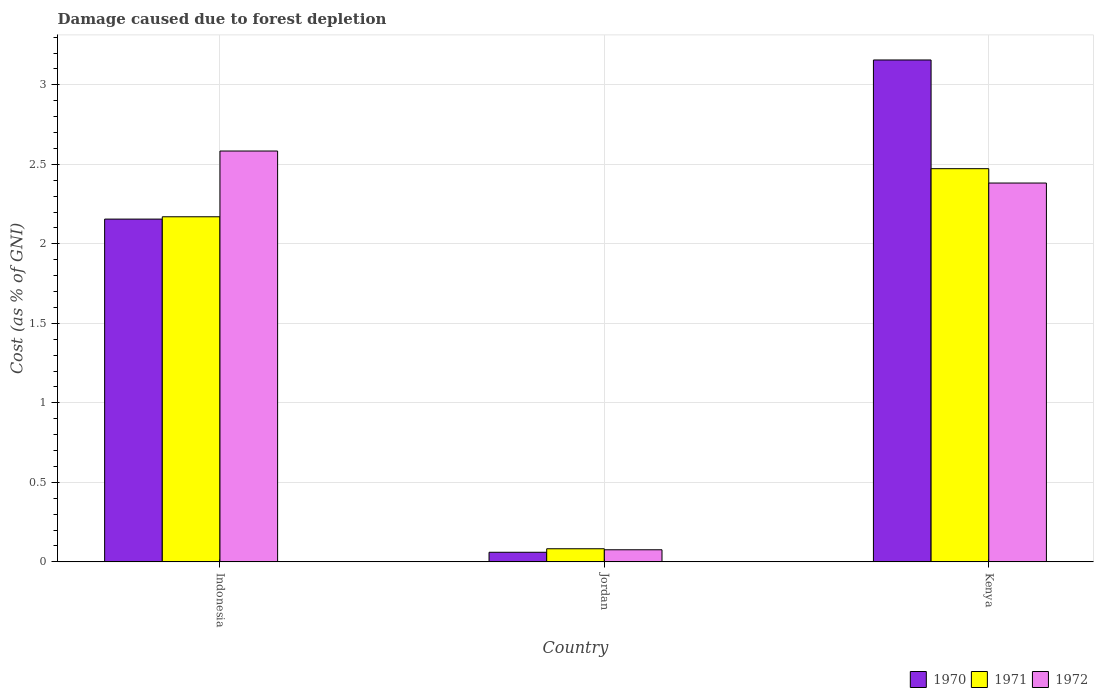How many different coloured bars are there?
Ensure brevity in your answer.  3. How many groups of bars are there?
Your answer should be compact. 3. Are the number of bars per tick equal to the number of legend labels?
Your response must be concise. Yes. How many bars are there on the 1st tick from the left?
Offer a very short reply. 3. What is the label of the 3rd group of bars from the left?
Offer a terse response. Kenya. What is the cost of damage caused due to forest depletion in 1972 in Indonesia?
Your response must be concise. 2.58. Across all countries, what is the maximum cost of damage caused due to forest depletion in 1972?
Give a very brief answer. 2.58. Across all countries, what is the minimum cost of damage caused due to forest depletion in 1970?
Your answer should be compact. 0.06. In which country was the cost of damage caused due to forest depletion in 1971 maximum?
Keep it short and to the point. Kenya. In which country was the cost of damage caused due to forest depletion in 1971 minimum?
Provide a succinct answer. Jordan. What is the total cost of damage caused due to forest depletion in 1970 in the graph?
Provide a succinct answer. 5.37. What is the difference between the cost of damage caused due to forest depletion in 1972 in Indonesia and that in Jordan?
Your answer should be compact. 2.51. What is the difference between the cost of damage caused due to forest depletion in 1972 in Kenya and the cost of damage caused due to forest depletion in 1970 in Indonesia?
Provide a succinct answer. 0.23. What is the average cost of damage caused due to forest depletion in 1972 per country?
Offer a terse response. 1.68. What is the difference between the cost of damage caused due to forest depletion of/in 1970 and cost of damage caused due to forest depletion of/in 1971 in Indonesia?
Your response must be concise. -0.01. In how many countries, is the cost of damage caused due to forest depletion in 1972 greater than 1.8 %?
Offer a very short reply. 2. What is the ratio of the cost of damage caused due to forest depletion in 1972 in Indonesia to that in Kenya?
Your answer should be very brief. 1.08. Is the cost of damage caused due to forest depletion in 1971 in Indonesia less than that in Kenya?
Keep it short and to the point. Yes. What is the difference between the highest and the second highest cost of damage caused due to forest depletion in 1970?
Give a very brief answer. -2.1. What is the difference between the highest and the lowest cost of damage caused due to forest depletion in 1972?
Offer a very short reply. 2.51. In how many countries, is the cost of damage caused due to forest depletion in 1971 greater than the average cost of damage caused due to forest depletion in 1971 taken over all countries?
Your answer should be compact. 2. Is the sum of the cost of damage caused due to forest depletion in 1970 in Indonesia and Jordan greater than the maximum cost of damage caused due to forest depletion in 1972 across all countries?
Ensure brevity in your answer.  No. What does the 3rd bar from the right in Jordan represents?
Your answer should be very brief. 1970. How many bars are there?
Your answer should be very brief. 9. Are all the bars in the graph horizontal?
Provide a short and direct response. No. Are the values on the major ticks of Y-axis written in scientific E-notation?
Offer a very short reply. No. What is the title of the graph?
Make the answer very short. Damage caused due to forest depletion. What is the label or title of the X-axis?
Keep it short and to the point. Country. What is the label or title of the Y-axis?
Offer a terse response. Cost (as % of GNI). What is the Cost (as % of GNI) in 1970 in Indonesia?
Offer a terse response. 2.16. What is the Cost (as % of GNI) in 1971 in Indonesia?
Give a very brief answer. 2.17. What is the Cost (as % of GNI) in 1972 in Indonesia?
Keep it short and to the point. 2.58. What is the Cost (as % of GNI) in 1970 in Jordan?
Offer a terse response. 0.06. What is the Cost (as % of GNI) of 1971 in Jordan?
Offer a terse response. 0.08. What is the Cost (as % of GNI) in 1972 in Jordan?
Your answer should be very brief. 0.08. What is the Cost (as % of GNI) of 1970 in Kenya?
Offer a terse response. 3.16. What is the Cost (as % of GNI) in 1971 in Kenya?
Give a very brief answer. 2.47. What is the Cost (as % of GNI) of 1972 in Kenya?
Give a very brief answer. 2.38. Across all countries, what is the maximum Cost (as % of GNI) of 1970?
Your answer should be very brief. 3.16. Across all countries, what is the maximum Cost (as % of GNI) of 1971?
Your answer should be very brief. 2.47. Across all countries, what is the maximum Cost (as % of GNI) in 1972?
Offer a terse response. 2.58. Across all countries, what is the minimum Cost (as % of GNI) in 1970?
Provide a succinct answer. 0.06. Across all countries, what is the minimum Cost (as % of GNI) of 1971?
Your answer should be compact. 0.08. Across all countries, what is the minimum Cost (as % of GNI) in 1972?
Give a very brief answer. 0.08. What is the total Cost (as % of GNI) in 1970 in the graph?
Keep it short and to the point. 5.37. What is the total Cost (as % of GNI) in 1971 in the graph?
Your answer should be compact. 4.73. What is the total Cost (as % of GNI) in 1972 in the graph?
Ensure brevity in your answer.  5.04. What is the difference between the Cost (as % of GNI) of 1970 in Indonesia and that in Jordan?
Ensure brevity in your answer.  2.1. What is the difference between the Cost (as % of GNI) of 1971 in Indonesia and that in Jordan?
Your response must be concise. 2.09. What is the difference between the Cost (as % of GNI) of 1972 in Indonesia and that in Jordan?
Provide a succinct answer. 2.51. What is the difference between the Cost (as % of GNI) in 1970 in Indonesia and that in Kenya?
Your response must be concise. -1. What is the difference between the Cost (as % of GNI) of 1971 in Indonesia and that in Kenya?
Ensure brevity in your answer.  -0.3. What is the difference between the Cost (as % of GNI) of 1972 in Indonesia and that in Kenya?
Offer a terse response. 0.2. What is the difference between the Cost (as % of GNI) in 1970 in Jordan and that in Kenya?
Your response must be concise. -3.1. What is the difference between the Cost (as % of GNI) of 1971 in Jordan and that in Kenya?
Give a very brief answer. -2.39. What is the difference between the Cost (as % of GNI) in 1972 in Jordan and that in Kenya?
Provide a short and direct response. -2.31. What is the difference between the Cost (as % of GNI) in 1970 in Indonesia and the Cost (as % of GNI) in 1971 in Jordan?
Ensure brevity in your answer.  2.07. What is the difference between the Cost (as % of GNI) in 1970 in Indonesia and the Cost (as % of GNI) in 1972 in Jordan?
Offer a terse response. 2.08. What is the difference between the Cost (as % of GNI) in 1971 in Indonesia and the Cost (as % of GNI) in 1972 in Jordan?
Offer a very short reply. 2.09. What is the difference between the Cost (as % of GNI) in 1970 in Indonesia and the Cost (as % of GNI) in 1971 in Kenya?
Offer a very short reply. -0.32. What is the difference between the Cost (as % of GNI) of 1970 in Indonesia and the Cost (as % of GNI) of 1972 in Kenya?
Make the answer very short. -0.23. What is the difference between the Cost (as % of GNI) of 1971 in Indonesia and the Cost (as % of GNI) of 1972 in Kenya?
Ensure brevity in your answer.  -0.21. What is the difference between the Cost (as % of GNI) of 1970 in Jordan and the Cost (as % of GNI) of 1971 in Kenya?
Make the answer very short. -2.41. What is the difference between the Cost (as % of GNI) of 1970 in Jordan and the Cost (as % of GNI) of 1972 in Kenya?
Offer a very short reply. -2.32. What is the difference between the Cost (as % of GNI) of 1971 in Jordan and the Cost (as % of GNI) of 1972 in Kenya?
Provide a short and direct response. -2.3. What is the average Cost (as % of GNI) in 1970 per country?
Provide a short and direct response. 1.79. What is the average Cost (as % of GNI) of 1971 per country?
Ensure brevity in your answer.  1.58. What is the average Cost (as % of GNI) in 1972 per country?
Provide a short and direct response. 1.68. What is the difference between the Cost (as % of GNI) of 1970 and Cost (as % of GNI) of 1971 in Indonesia?
Your response must be concise. -0.01. What is the difference between the Cost (as % of GNI) of 1970 and Cost (as % of GNI) of 1972 in Indonesia?
Provide a succinct answer. -0.43. What is the difference between the Cost (as % of GNI) of 1971 and Cost (as % of GNI) of 1972 in Indonesia?
Your response must be concise. -0.41. What is the difference between the Cost (as % of GNI) in 1970 and Cost (as % of GNI) in 1971 in Jordan?
Give a very brief answer. -0.02. What is the difference between the Cost (as % of GNI) of 1970 and Cost (as % of GNI) of 1972 in Jordan?
Make the answer very short. -0.02. What is the difference between the Cost (as % of GNI) of 1971 and Cost (as % of GNI) of 1972 in Jordan?
Provide a short and direct response. 0.01. What is the difference between the Cost (as % of GNI) in 1970 and Cost (as % of GNI) in 1971 in Kenya?
Keep it short and to the point. 0.68. What is the difference between the Cost (as % of GNI) of 1970 and Cost (as % of GNI) of 1972 in Kenya?
Offer a terse response. 0.77. What is the difference between the Cost (as % of GNI) of 1971 and Cost (as % of GNI) of 1972 in Kenya?
Ensure brevity in your answer.  0.09. What is the ratio of the Cost (as % of GNI) of 1970 in Indonesia to that in Jordan?
Provide a succinct answer. 35.71. What is the ratio of the Cost (as % of GNI) of 1971 in Indonesia to that in Jordan?
Ensure brevity in your answer.  26.32. What is the ratio of the Cost (as % of GNI) of 1972 in Indonesia to that in Jordan?
Ensure brevity in your answer.  33.95. What is the ratio of the Cost (as % of GNI) of 1970 in Indonesia to that in Kenya?
Your answer should be compact. 0.68. What is the ratio of the Cost (as % of GNI) of 1971 in Indonesia to that in Kenya?
Your answer should be compact. 0.88. What is the ratio of the Cost (as % of GNI) of 1972 in Indonesia to that in Kenya?
Your answer should be very brief. 1.08. What is the ratio of the Cost (as % of GNI) of 1970 in Jordan to that in Kenya?
Give a very brief answer. 0.02. What is the ratio of the Cost (as % of GNI) in 1971 in Jordan to that in Kenya?
Your response must be concise. 0.03. What is the ratio of the Cost (as % of GNI) of 1972 in Jordan to that in Kenya?
Provide a short and direct response. 0.03. What is the difference between the highest and the second highest Cost (as % of GNI) in 1971?
Provide a short and direct response. 0.3. What is the difference between the highest and the second highest Cost (as % of GNI) in 1972?
Ensure brevity in your answer.  0.2. What is the difference between the highest and the lowest Cost (as % of GNI) in 1970?
Provide a succinct answer. 3.1. What is the difference between the highest and the lowest Cost (as % of GNI) of 1971?
Give a very brief answer. 2.39. What is the difference between the highest and the lowest Cost (as % of GNI) of 1972?
Keep it short and to the point. 2.51. 